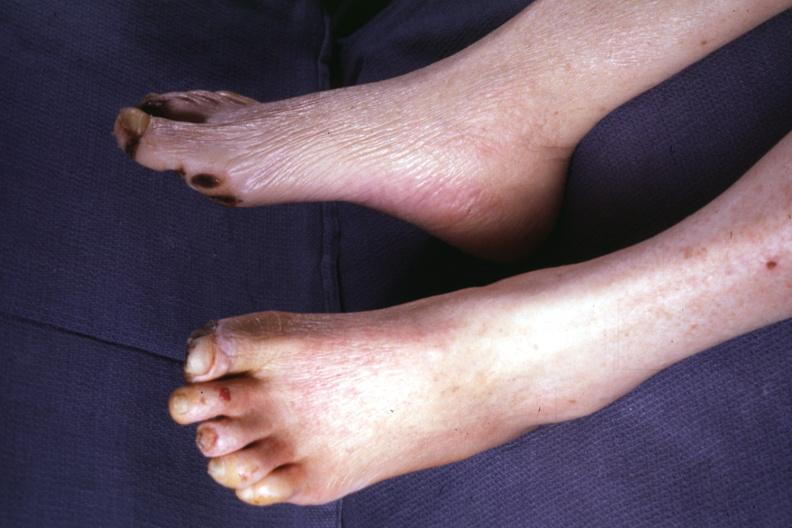s hours present?
Answer the question using a single word or phrase. No 